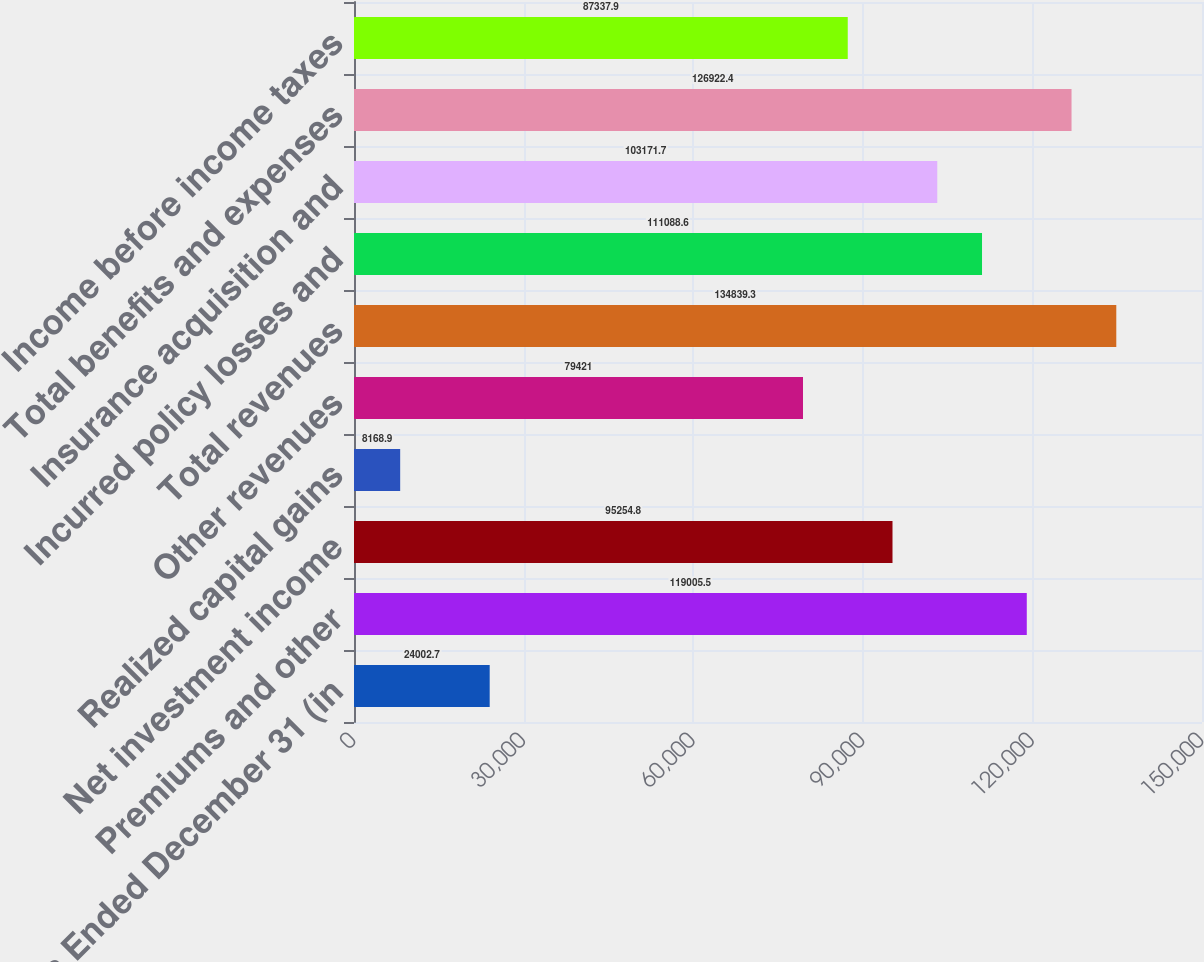Convert chart. <chart><loc_0><loc_0><loc_500><loc_500><bar_chart><fcel>Years Ended December 31 (in<fcel>Premiums and other<fcel>Net investment income<fcel>Realized capital gains<fcel>Other revenues<fcel>Total revenues<fcel>Incurred policy losses and<fcel>Insurance acquisition and<fcel>Total benefits and expenses<fcel>Income before income taxes<nl><fcel>24002.7<fcel>119006<fcel>95254.8<fcel>8168.9<fcel>79421<fcel>134839<fcel>111089<fcel>103172<fcel>126922<fcel>87337.9<nl></chart> 